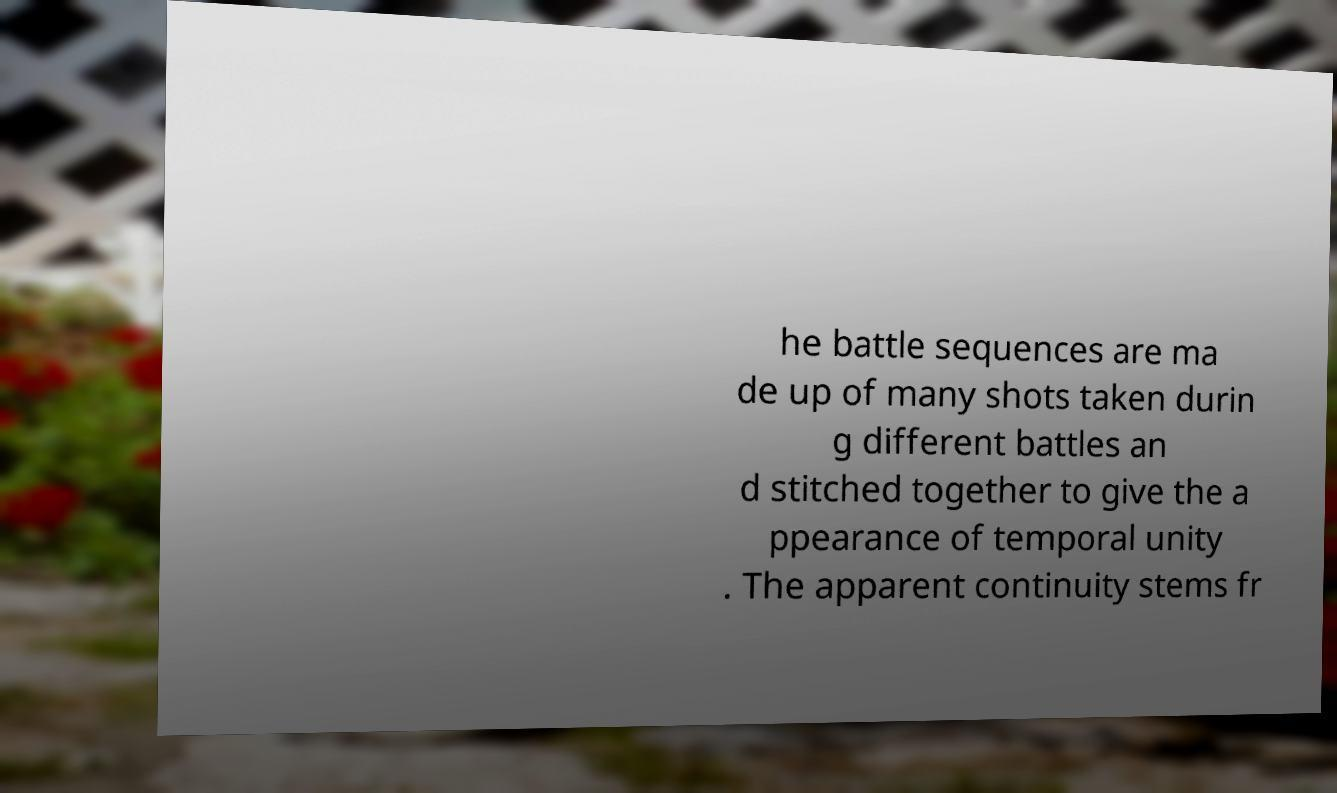Could you extract and type out the text from this image? he battle sequences are ma de up of many shots taken durin g different battles an d stitched together to give the a ppearance of temporal unity . The apparent continuity stems fr 